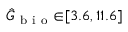<formula> <loc_0><loc_0><loc_500><loc_500>\hat { G } _ { b i o } { \in } [ 3 . 6 , 1 1 . 6 ]</formula> 